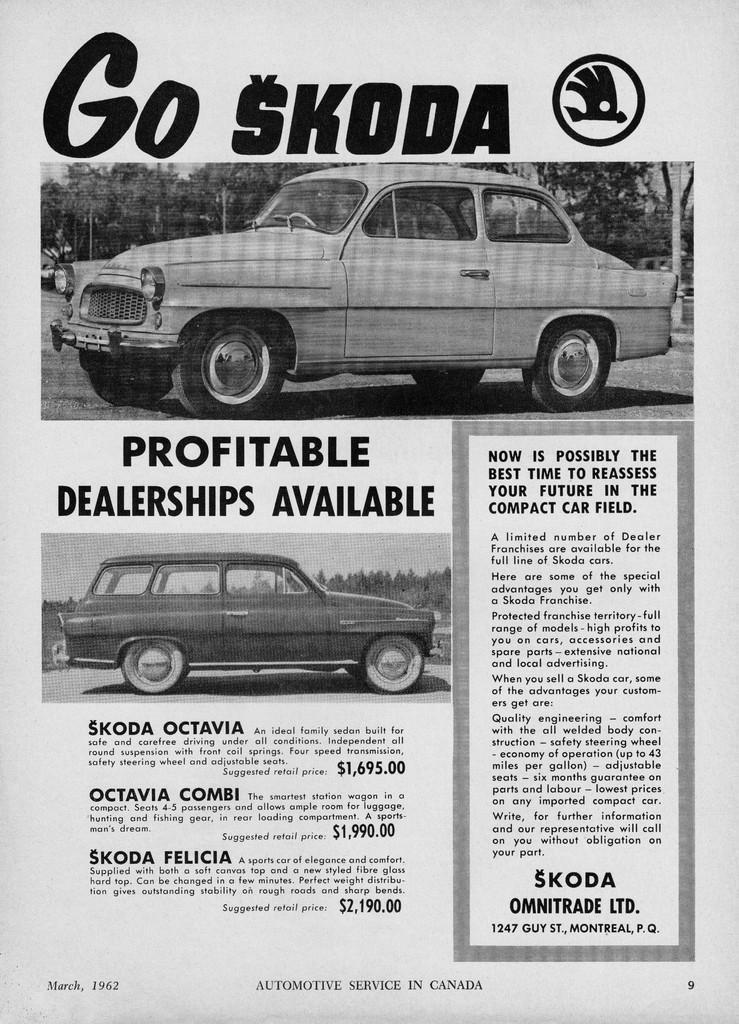In one or two sentences, can you explain what this image depicts? In this image there is some text written on it and there are images of the cars and trees. 